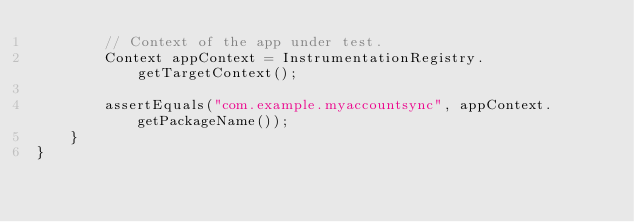<code> <loc_0><loc_0><loc_500><loc_500><_Java_>        // Context of the app under test.
        Context appContext = InstrumentationRegistry.getTargetContext();

        assertEquals("com.example.myaccountsync", appContext.getPackageName());
    }
}
</code> 